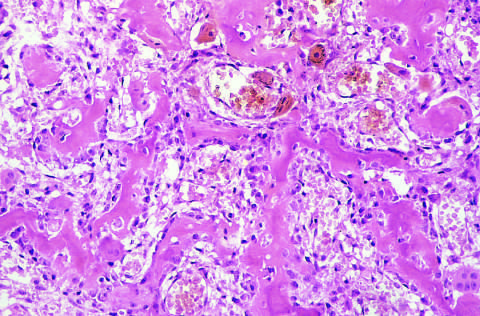what are the intertrabecular spaces filled by?
Answer the question using a single word or phrase. Vascularized loose connective tissue 